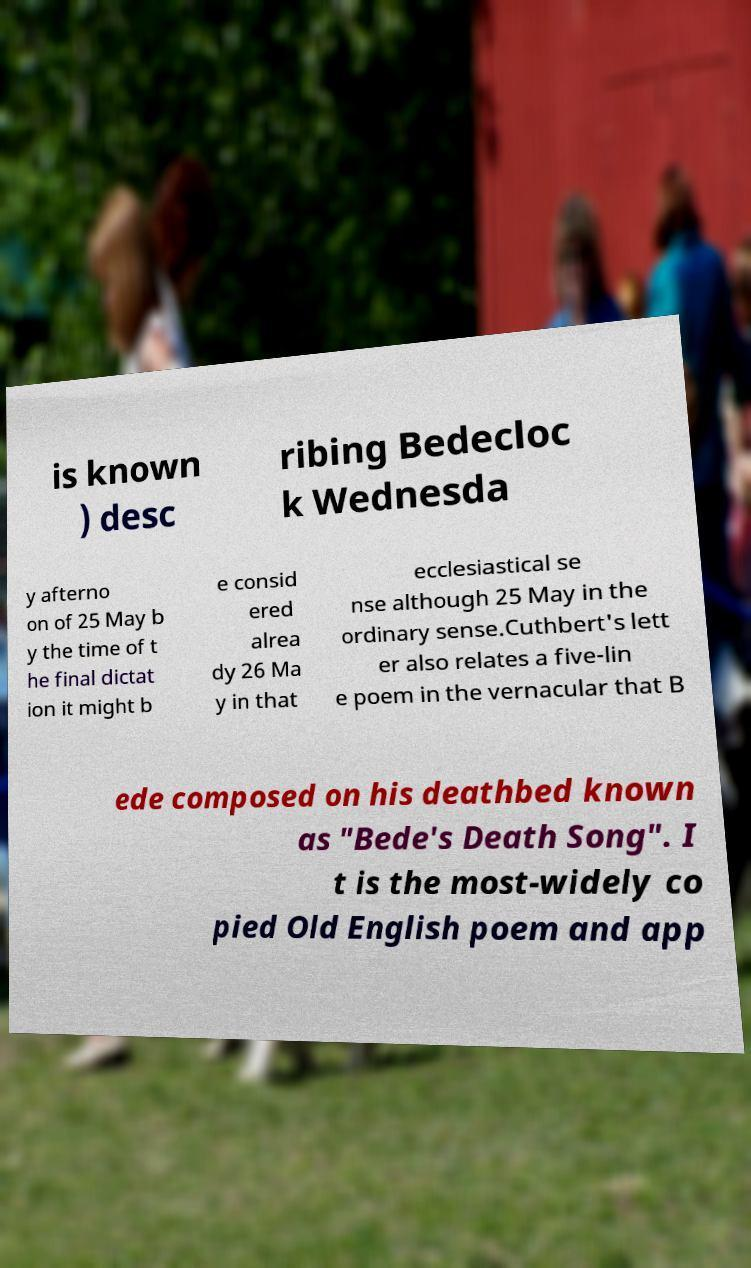What messages or text are displayed in this image? I need them in a readable, typed format. is known ) desc ribing Bedecloc k Wednesda y afterno on of 25 May b y the time of t he final dictat ion it might b e consid ered alrea dy 26 Ma y in that ecclesiastical se nse although 25 May in the ordinary sense.Cuthbert's lett er also relates a five-lin e poem in the vernacular that B ede composed on his deathbed known as "Bede's Death Song". I t is the most-widely co pied Old English poem and app 